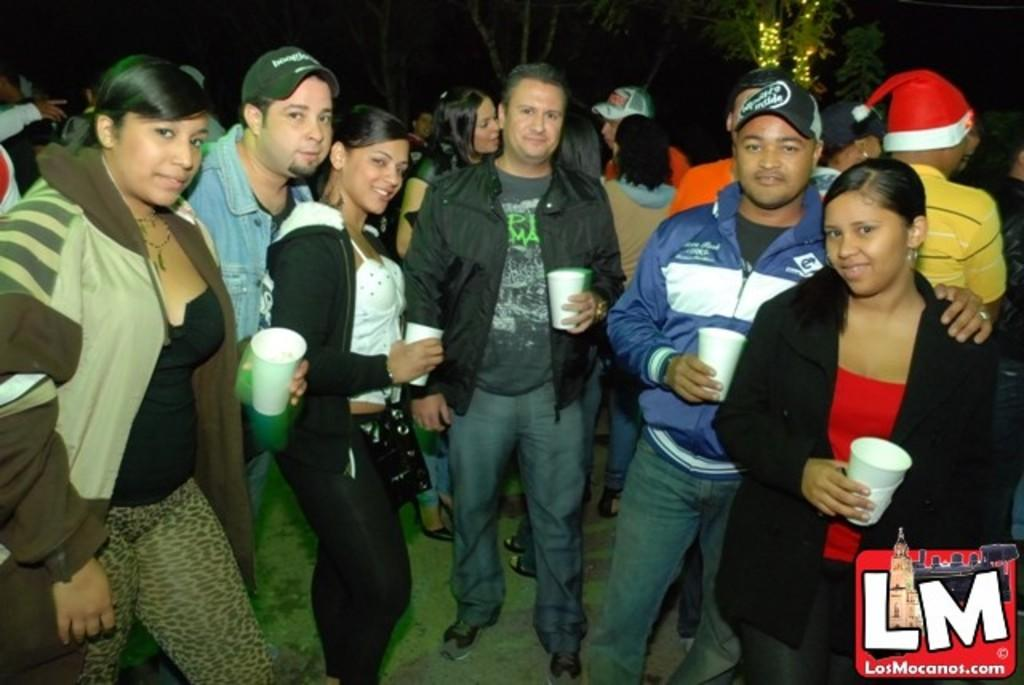How many people are present in the image? There are many people in the image. What are some people wearing in the image? Some people are wearing caps in the image. What are some people holding in the image? Some people are holding cups in the image. What can be seen in the background of the image? There are trees and lights in the background of the image. Where is the watermark located in the image? The watermark is in the right bottom corner of the image. What type of sweater is the building wearing in the image? There is no building present in the image, and buildings do not wear sweaters. What appliance is being used by the people in the image? The provided facts do not mention any appliances being used by the people in the image. 